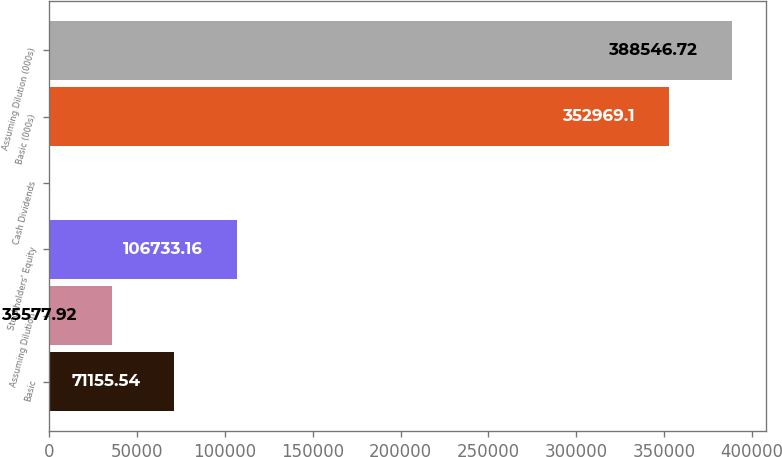Convert chart to OTSL. <chart><loc_0><loc_0><loc_500><loc_500><bar_chart><fcel>Basic<fcel>Assuming Dilution<fcel>Stockholders' Equity<fcel>Cash Dividends<fcel>Basic (000s)<fcel>Assuming Dilution (000s)<nl><fcel>71155.5<fcel>35577.9<fcel>106733<fcel>0.3<fcel>352969<fcel>388547<nl></chart> 